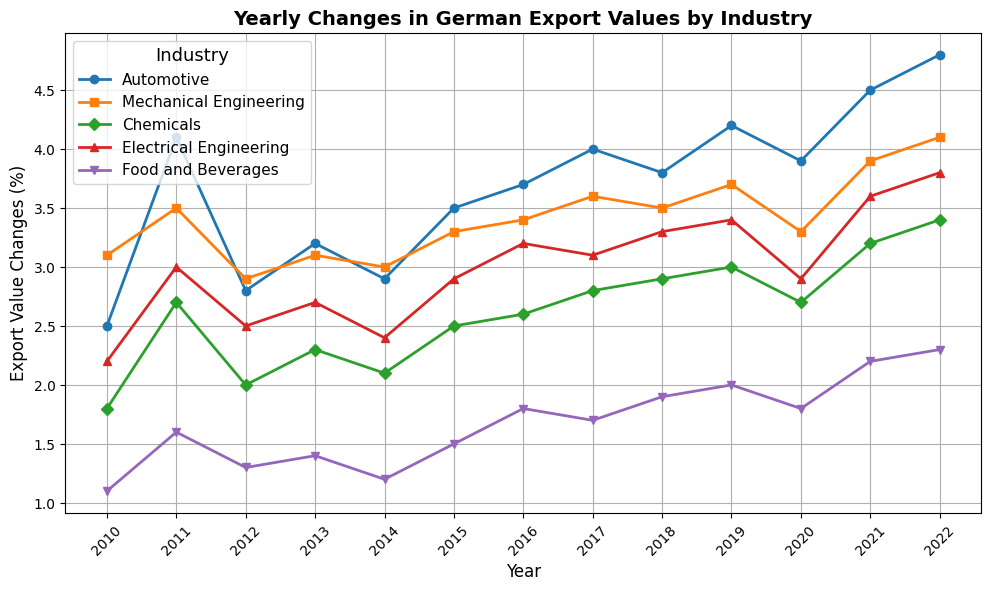What's the difference in export values for the Automotive industry between 2010 and 2022? First, identify the export values for the Automotive industry for the years 2010 and 2022 on the plot. These values are 2.5% and 4.8% respectively. Then, subtract the 2010 value from the 2022 value: 4.8 - 2.5 = 2.3
Answer: 2.3 Which industry had the highest export value change in 2022? Look at the export value changes for all industries in 2022 on the plot and compare them. The values are as follows: Automotive (4.8%), Mechanical Engineering (4.1%), Chemicals (3.4%), Electrical Engineering (3.8%), Food and Beverages (2.3%). The highest value is from the Automotive industry (4.8%).
Answer: Automotive Between which consecutive years did the Mechanical Engineering industry experience the largest increase? Inspect the plot and identify the export values for the Mechanical Engineering industry for each year. Calculate the year-to-year change and find the largest increase: 
* 2010-2011: 3.5 - 3.1 = 0.4
* 2011-2012: 2.9 - 3.5 = -0.6
* 2012-2013: 3.1 - 2.9 = 0.2
* 2013-2014: 3.0 - 3.1 = -0.1
* 2014-2015: 3.3 - 3.0 = 0.3
* 2015-2016: 3.4 - 3.3 = 0.1
* 2016-2017: 3.6 - 3.4 = 0.2
* 2017-2018: 3.5 - 3.6 = -0.1
* 2018-2019: 3.7 - 3.5 = 0.2
* 2019-2020: 3.3 - 3.7 = -0.4
* 2020-2021: 3.9 - 3.3 = 0.6
* 2021-2022: 4.1 - 3.9 = 0.2
The largest increase is from 2020 to 2021, with an increase of 0.6.
Answer: 2020-2021 Which industry had the highest average export value change over the entire period? Calculate the average export value change for each industry by summing their yearly values and dividing by the number of years (13 years):
* Automotive: (2.5 + 4.1 + 2.8 + 3.2 + 2.9 + 3.5 + 3.7 + 4.0 + 3.8 + 4.2 + 3.9 + 4.5 + 4.8) / 13 ≈ 3.62
* Mechanical Engineering: (3.1 + 3.5 + 2.9 + 3.1 + 3.0 + 3.3 + 3.4 + 3.6 + 3.5 + 3.7 + 3.3 + 3.9 + 4.1) / 13 ≈ 3.32
* Chemicals: (1.8 + 2.7 + 2.0 + 2.3 + 2.1 + 2.5 + 2.6 + 2.8 + 2.9 + 3.0 + 2.7 + 3.2 + 3.4) / 13 ≈ 2.61
* Electrical Engineering: (2.2 + 3.0 + 2.5 + 2.7 + 2.4 + 2.9 + 3.2 + 3.1 + 3.3 + 3.4 + 2.9 + 3.6 + 3.8) / 13 ≈ 3.00
* Food and Beverages: (1.1 + 1.6 + 1.3 + 1.4 + 1.2 + 1.5 + 1.8 + 1.7 + 1.9 + 2.0 + 1.8 + 2.2 + 2.3) / 13 ≈ 1.64
The industry with the highest average export value change is Automotive.
Answer: Automotive In which year did the Chemicals industry see a notable increase compared to the previous year? Review the plot for the Chemicals industry and observe the changes in export values year-to-year:
* 2010 to 2011: 2.7 - 1.8 = 0.9
* 2011 to 2012: 2.0 - 2.7 = -0.7
* 2012 to 2013: 2.3 - 2.0 = 0.3
* 2013 to 2014: 2.1 - 2.3 = -0.2
* 2014 to 2015: 2.5 - 2.1 = 0.4
* 2015 to 2016: 2.6 - 2.5 = 0.1
* 2016 to 2017: 2.8 - 2.6 = 0.2
* 2017 to 2018: 2.9 - 2.8 = 0.1
* 2018 to 2019: 3.0 - 2.9 = 0.1
* 2019 to 2020: 2.7 - 3.0 = -0.3
* 2020 to 2021: 3.2 - 2.7 = 0.5
* 2021 to 2022: 3.4 - 3.2 = 0.2
The most notable increase was from 2010 to 2011, with an increase of 0.9.
Answer: 2010-2011 